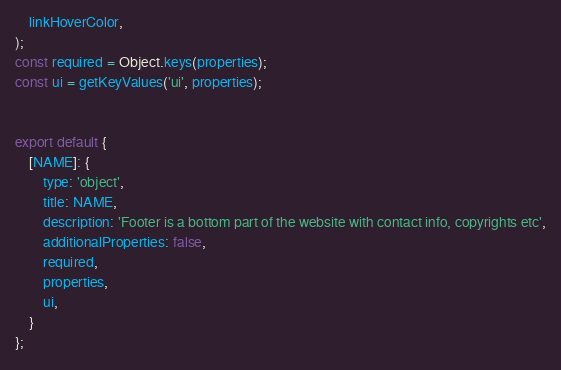<code> <loc_0><loc_0><loc_500><loc_500><_JavaScript_>    linkHoverColor,
);
const required = Object.keys(properties);
const ui = getKeyValues('ui', properties);


export default {
    [NAME]: {
        type: 'object',
        title: NAME,
        description: 'Footer is a bottom part of the website with contact info, copyrights etc',
        additionalProperties: false,
        required,
        properties,
        ui,
    }
};
</code> 